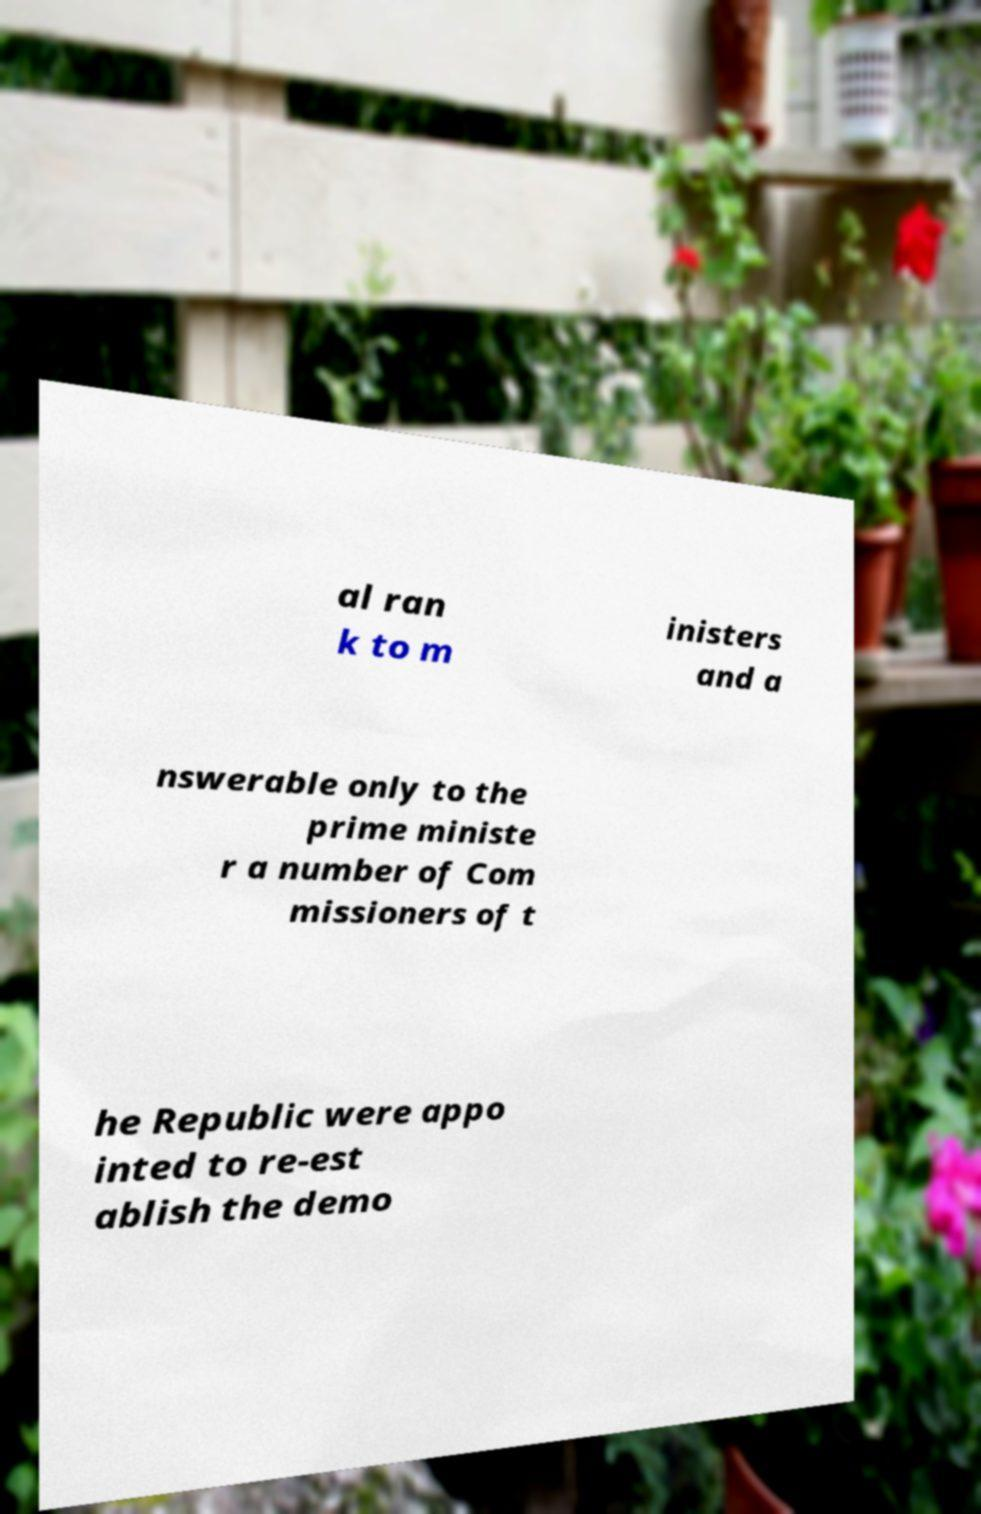Could you extract and type out the text from this image? al ran k to m inisters and a nswerable only to the prime ministe r a number of Com missioners of t he Republic were appo inted to re-est ablish the demo 